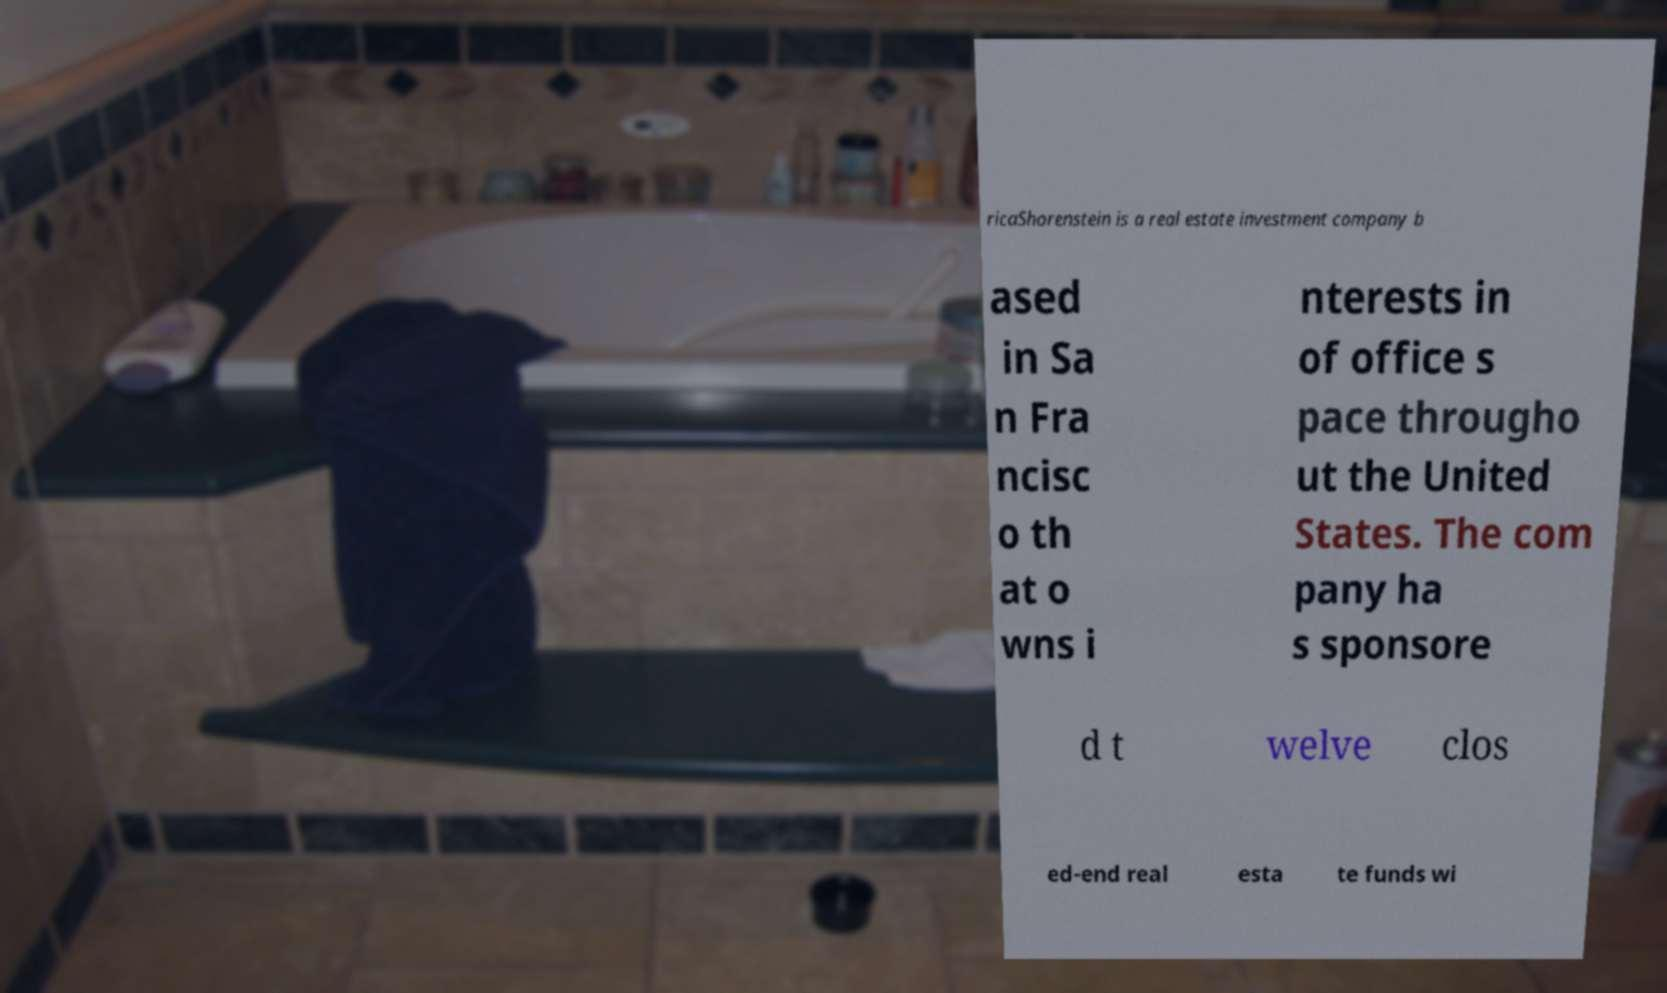I need the written content from this picture converted into text. Can you do that? ricaShorenstein is a real estate investment company b ased in Sa n Fra ncisc o th at o wns i nterests in of office s pace througho ut the United States. The com pany ha s sponsore d t welve clos ed-end real esta te funds wi 